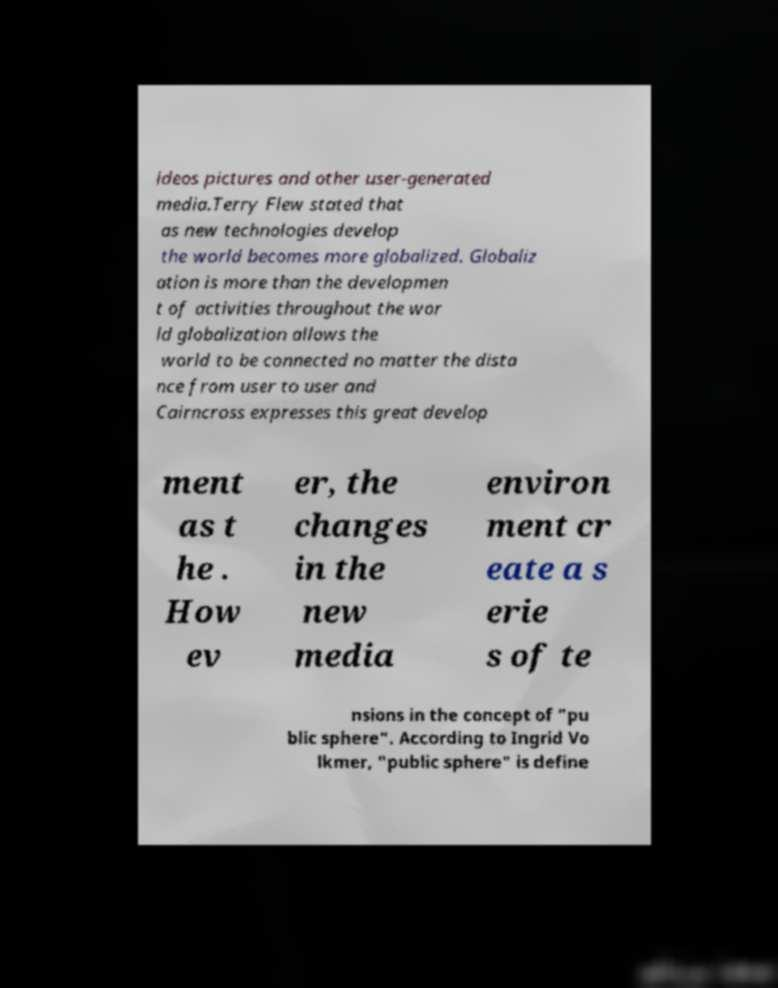For documentation purposes, I need the text within this image transcribed. Could you provide that? ideos pictures and other user-generated media.Terry Flew stated that as new technologies develop the world becomes more globalized. Globaliz ation is more than the developmen t of activities throughout the wor ld globalization allows the world to be connected no matter the dista nce from user to user and Cairncross expresses this great develop ment as t he . How ev er, the changes in the new media environ ment cr eate a s erie s of te nsions in the concept of "pu blic sphere". According to Ingrid Vo lkmer, "public sphere" is define 